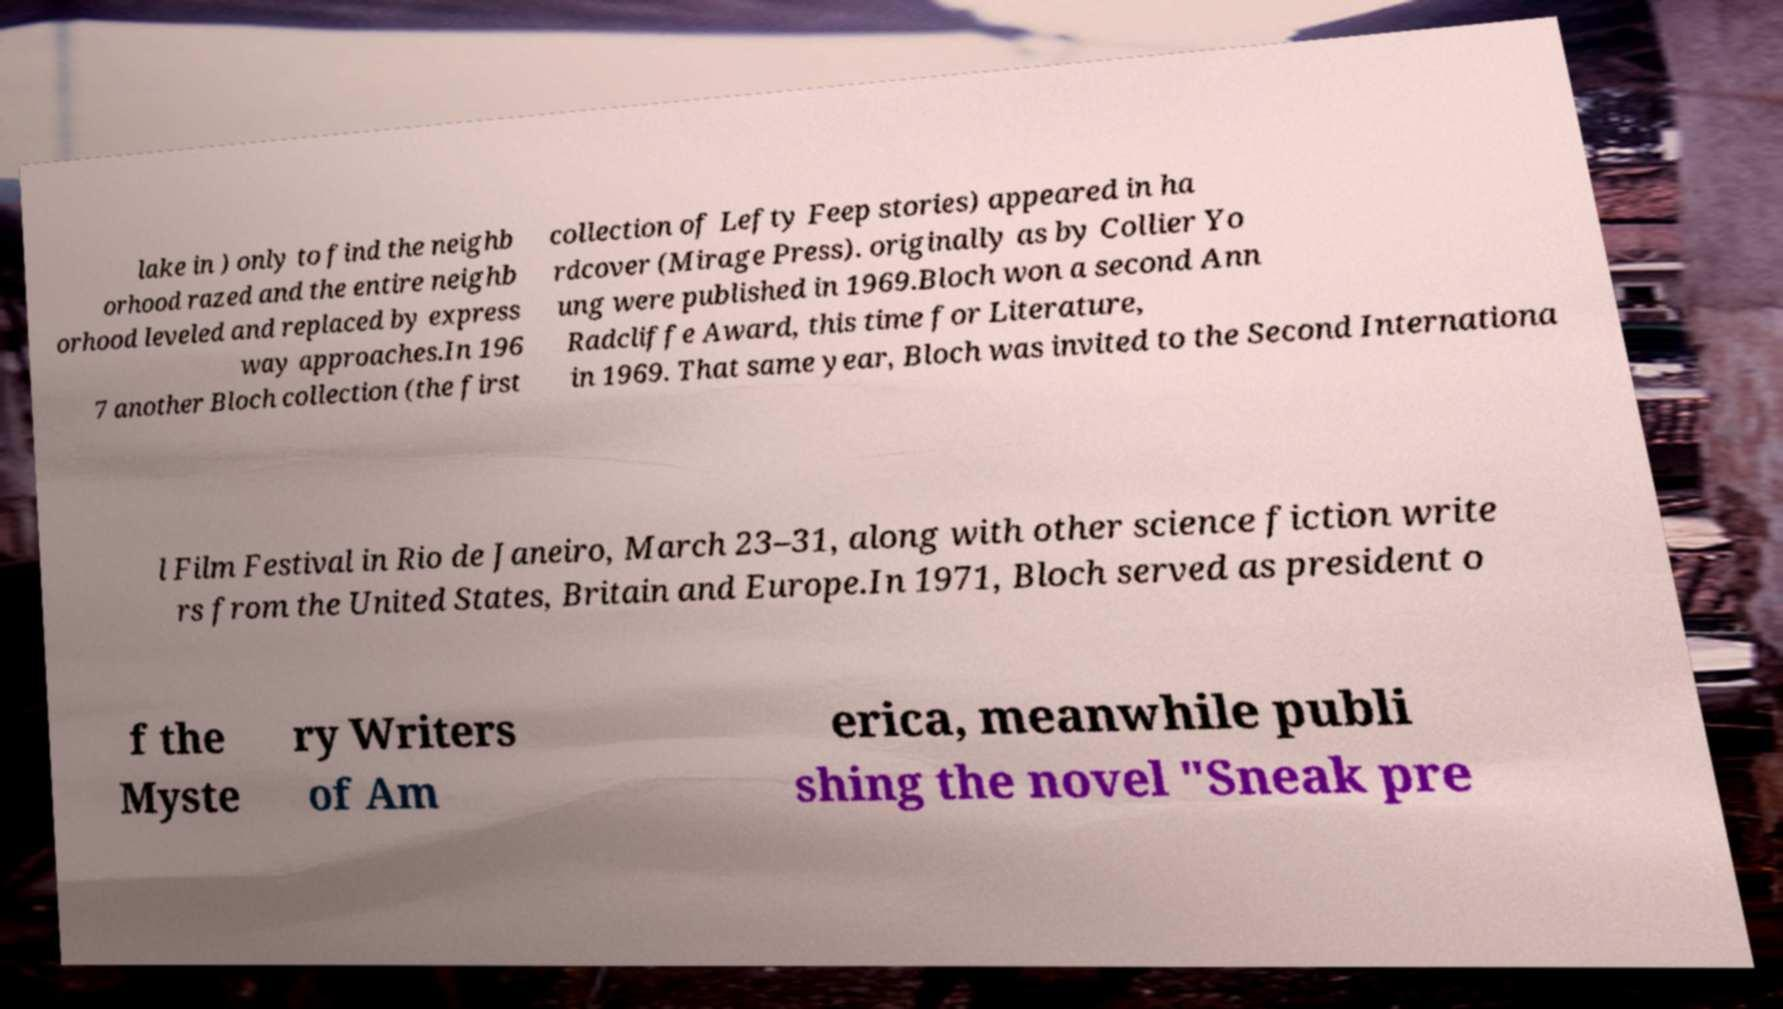There's text embedded in this image that I need extracted. Can you transcribe it verbatim? lake in ) only to find the neighb orhood razed and the entire neighb orhood leveled and replaced by express way approaches.In 196 7 another Bloch collection (the first collection of Lefty Feep stories) appeared in ha rdcover (Mirage Press). originally as by Collier Yo ung were published in 1969.Bloch won a second Ann Radcliffe Award, this time for Literature, in 1969. That same year, Bloch was invited to the Second Internationa l Film Festival in Rio de Janeiro, March 23–31, along with other science fiction write rs from the United States, Britain and Europe.In 1971, Bloch served as president o f the Myste ry Writers of Am erica, meanwhile publi shing the novel "Sneak pre 